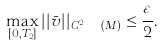<formula> <loc_0><loc_0><loc_500><loc_500>\max _ { [ 0 , T _ { 2 } ] } | | \bar { v } | | _ { C ^ { 2 , \ a } ( M ) } \leq \frac { \varepsilon } { 2 } .</formula> 